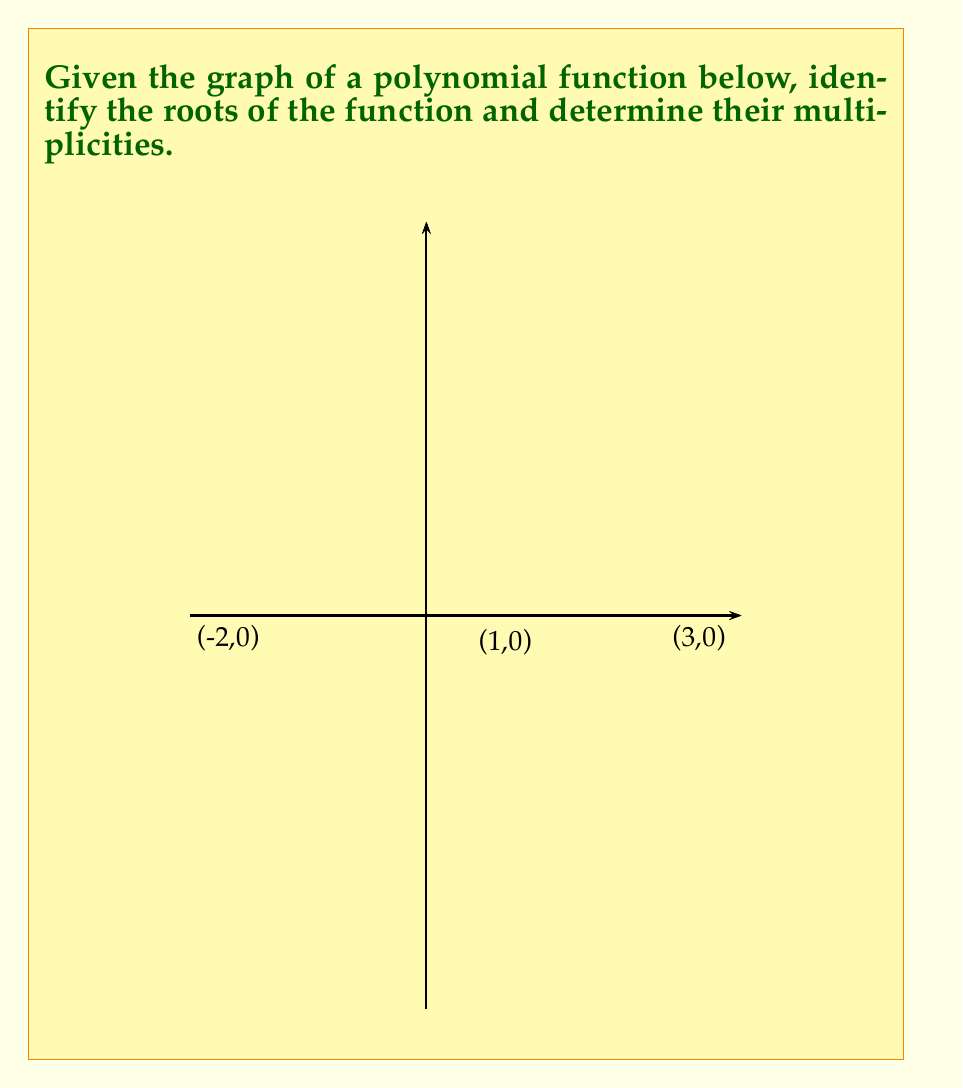Could you help me with this problem? To identify the roots and their multiplicities from the graph, we need to look at where the polynomial crosses or touches the x-axis. Let's go through this step-by-step:

1) The roots of a polynomial function are the x-coordinates of the points where the graph crosses or touches the x-axis (y = 0).

2) From the graph, we can see three distinct x-intercepts:
   a) x = -2
   b) x = 1
   c) x = 3

3) To determine the multiplicity of each root, we need to observe how the graph behaves at each x-intercept:

   a) At x = -2: The graph touches the x-axis but doesn't cross it. It forms a "U" shape, which is characteristic of a root with multiplicity 2.
   
   b) At x = 1: The graph crosses the x-axis, changing from negative to positive. This is characteristic of a root with multiplicity 1.
   
   c) At x = 3: The graph crosses the x-axis, changing from positive to negative. This is also characteristic of a root with multiplicity 1.

4) Therefore, we can conclude that:
   - The root x = -2 has multiplicity 2
   - The root x = 1 has multiplicity 1
   - The root x = 3 has multiplicity 1

5) We can express this polynomial in factored form as:

   $$f(x) = a(x+2)^2(x-1)(x-3)$$

   where $a$ is some non-zero constant.
Answer: Roots: -2 (multiplicity 2), 1 (multiplicity 1), 3 (multiplicity 1) 